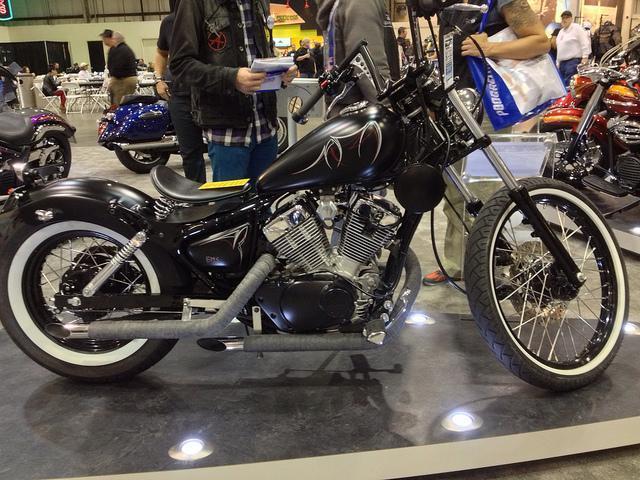How many motorcycles are in the photo?
Give a very brief answer. 4. How many people can be seen?
Give a very brief answer. 3. 